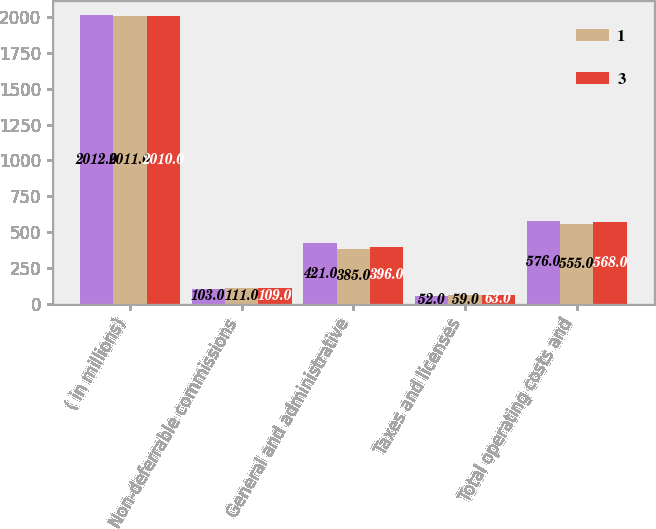Convert chart to OTSL. <chart><loc_0><loc_0><loc_500><loc_500><stacked_bar_chart><ecel><fcel>( in millions)<fcel>Non-deferrable commissions<fcel>General and administrative<fcel>Taxes and licenses<fcel>Total operating costs and<nl><fcel>nan<fcel>2012<fcel>103<fcel>421<fcel>52<fcel>576<nl><fcel>1<fcel>2011<fcel>111<fcel>385<fcel>59<fcel>555<nl><fcel>3<fcel>2010<fcel>109<fcel>396<fcel>63<fcel>568<nl></chart> 